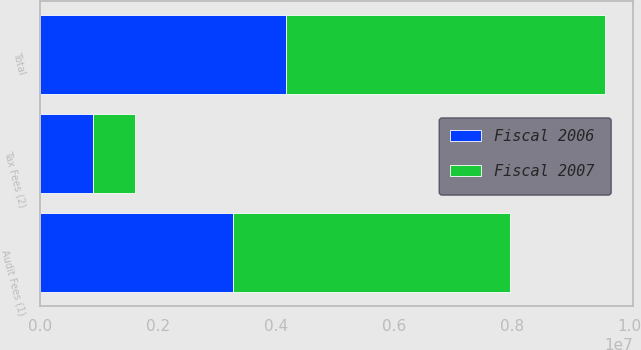Convert chart to OTSL. <chart><loc_0><loc_0><loc_500><loc_500><stacked_bar_chart><ecel><fcel>Audit Fees (1)<fcel>Tax Fees (2)<fcel>Total<nl><fcel>Fiscal 2007<fcel>4.70735e+06<fcel>707641<fcel>5.41499e+06<nl><fcel>Fiscal 2006<fcel>3.26598e+06<fcel>896835<fcel>4.16281e+06<nl></chart> 